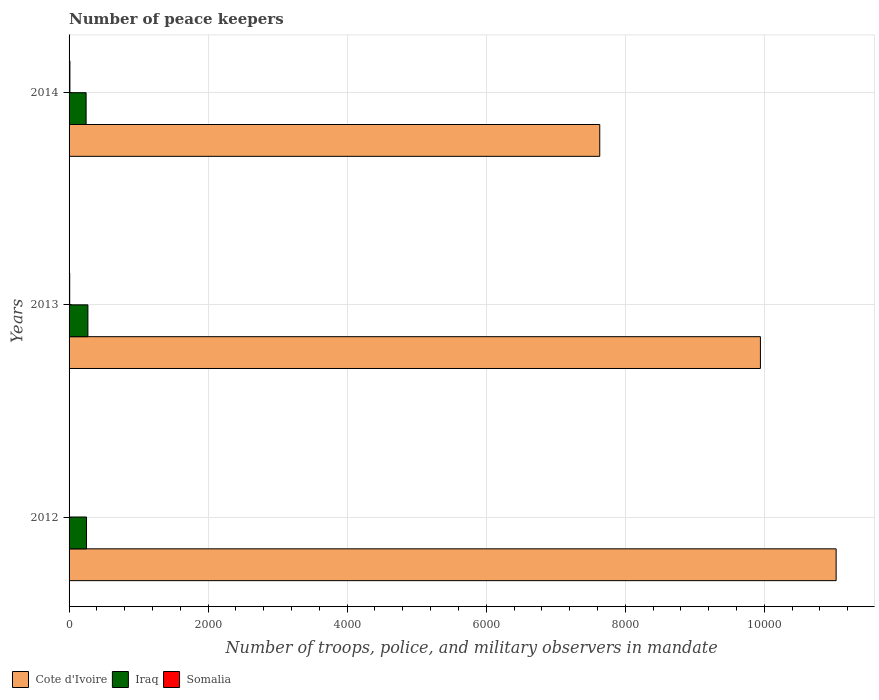How many different coloured bars are there?
Ensure brevity in your answer.  3. How many groups of bars are there?
Ensure brevity in your answer.  3. How many bars are there on the 2nd tick from the top?
Give a very brief answer. 3. How many bars are there on the 2nd tick from the bottom?
Provide a succinct answer. 3. What is the label of the 1st group of bars from the top?
Provide a short and direct response. 2014. What is the number of peace keepers in in Somalia in 2012?
Provide a short and direct response. 3. Across all years, what is the maximum number of peace keepers in in Somalia?
Make the answer very short. 12. Across all years, what is the minimum number of peace keepers in in Cote d'Ivoire?
Your answer should be compact. 7633. In which year was the number of peace keepers in in Iraq maximum?
Ensure brevity in your answer.  2013. What is the difference between the number of peace keepers in in Cote d'Ivoire in 2012 and that in 2013?
Give a very brief answer. 1089. What is the difference between the number of peace keepers in in Somalia in 2013 and the number of peace keepers in in Iraq in 2012?
Your response must be concise. -242. What is the average number of peace keepers in in Iraq per year?
Ensure brevity in your answer.  255.67. In the year 2014, what is the difference between the number of peace keepers in in Somalia and number of peace keepers in in Iraq?
Your response must be concise. -233. In how many years, is the number of peace keepers in in Iraq greater than 3600 ?
Your response must be concise. 0. Is the number of peace keepers in in Iraq in 2012 less than that in 2013?
Offer a terse response. Yes. What is the difference between the highest and the second highest number of peace keepers in in Iraq?
Give a very brief answer. 20. What does the 3rd bar from the top in 2012 represents?
Your answer should be compact. Cote d'Ivoire. What does the 1st bar from the bottom in 2014 represents?
Your answer should be compact. Cote d'Ivoire. How many bars are there?
Ensure brevity in your answer.  9. How many years are there in the graph?
Your answer should be very brief. 3. Does the graph contain grids?
Your answer should be very brief. Yes. Where does the legend appear in the graph?
Offer a terse response. Bottom left. How many legend labels are there?
Your answer should be compact. 3. What is the title of the graph?
Give a very brief answer. Number of peace keepers. Does "Venezuela" appear as one of the legend labels in the graph?
Your answer should be very brief. No. What is the label or title of the X-axis?
Provide a succinct answer. Number of troops, police, and military observers in mandate. What is the Number of troops, police, and military observers in mandate of Cote d'Ivoire in 2012?
Offer a terse response. 1.10e+04. What is the Number of troops, police, and military observers in mandate in Iraq in 2012?
Provide a short and direct response. 251. What is the Number of troops, police, and military observers in mandate in Somalia in 2012?
Your answer should be compact. 3. What is the Number of troops, police, and military observers in mandate in Cote d'Ivoire in 2013?
Your answer should be compact. 9944. What is the Number of troops, police, and military observers in mandate in Iraq in 2013?
Ensure brevity in your answer.  271. What is the Number of troops, police, and military observers in mandate of Somalia in 2013?
Offer a terse response. 9. What is the Number of troops, police, and military observers in mandate of Cote d'Ivoire in 2014?
Offer a very short reply. 7633. What is the Number of troops, police, and military observers in mandate in Iraq in 2014?
Provide a succinct answer. 245. Across all years, what is the maximum Number of troops, police, and military observers in mandate of Cote d'Ivoire?
Offer a terse response. 1.10e+04. Across all years, what is the maximum Number of troops, police, and military observers in mandate of Iraq?
Give a very brief answer. 271. Across all years, what is the maximum Number of troops, police, and military observers in mandate of Somalia?
Provide a short and direct response. 12. Across all years, what is the minimum Number of troops, police, and military observers in mandate in Cote d'Ivoire?
Keep it short and to the point. 7633. Across all years, what is the minimum Number of troops, police, and military observers in mandate of Iraq?
Keep it short and to the point. 245. Across all years, what is the minimum Number of troops, police, and military observers in mandate in Somalia?
Keep it short and to the point. 3. What is the total Number of troops, police, and military observers in mandate of Cote d'Ivoire in the graph?
Your answer should be very brief. 2.86e+04. What is the total Number of troops, police, and military observers in mandate of Iraq in the graph?
Your answer should be very brief. 767. What is the difference between the Number of troops, police, and military observers in mandate in Cote d'Ivoire in 2012 and that in 2013?
Make the answer very short. 1089. What is the difference between the Number of troops, police, and military observers in mandate in Cote d'Ivoire in 2012 and that in 2014?
Your response must be concise. 3400. What is the difference between the Number of troops, police, and military observers in mandate of Cote d'Ivoire in 2013 and that in 2014?
Provide a short and direct response. 2311. What is the difference between the Number of troops, police, and military observers in mandate of Cote d'Ivoire in 2012 and the Number of troops, police, and military observers in mandate of Iraq in 2013?
Provide a succinct answer. 1.08e+04. What is the difference between the Number of troops, police, and military observers in mandate in Cote d'Ivoire in 2012 and the Number of troops, police, and military observers in mandate in Somalia in 2013?
Your response must be concise. 1.10e+04. What is the difference between the Number of troops, police, and military observers in mandate in Iraq in 2012 and the Number of troops, police, and military observers in mandate in Somalia in 2013?
Provide a short and direct response. 242. What is the difference between the Number of troops, police, and military observers in mandate of Cote d'Ivoire in 2012 and the Number of troops, police, and military observers in mandate of Iraq in 2014?
Offer a very short reply. 1.08e+04. What is the difference between the Number of troops, police, and military observers in mandate in Cote d'Ivoire in 2012 and the Number of troops, police, and military observers in mandate in Somalia in 2014?
Give a very brief answer. 1.10e+04. What is the difference between the Number of troops, police, and military observers in mandate in Iraq in 2012 and the Number of troops, police, and military observers in mandate in Somalia in 2014?
Provide a succinct answer. 239. What is the difference between the Number of troops, police, and military observers in mandate of Cote d'Ivoire in 2013 and the Number of troops, police, and military observers in mandate of Iraq in 2014?
Your answer should be compact. 9699. What is the difference between the Number of troops, police, and military observers in mandate in Cote d'Ivoire in 2013 and the Number of troops, police, and military observers in mandate in Somalia in 2014?
Keep it short and to the point. 9932. What is the difference between the Number of troops, police, and military observers in mandate in Iraq in 2013 and the Number of troops, police, and military observers in mandate in Somalia in 2014?
Provide a succinct answer. 259. What is the average Number of troops, police, and military observers in mandate in Cote d'Ivoire per year?
Provide a short and direct response. 9536.67. What is the average Number of troops, police, and military observers in mandate in Iraq per year?
Provide a short and direct response. 255.67. In the year 2012, what is the difference between the Number of troops, police, and military observers in mandate of Cote d'Ivoire and Number of troops, police, and military observers in mandate of Iraq?
Provide a succinct answer. 1.08e+04. In the year 2012, what is the difference between the Number of troops, police, and military observers in mandate of Cote d'Ivoire and Number of troops, police, and military observers in mandate of Somalia?
Give a very brief answer. 1.10e+04. In the year 2012, what is the difference between the Number of troops, police, and military observers in mandate in Iraq and Number of troops, police, and military observers in mandate in Somalia?
Your answer should be compact. 248. In the year 2013, what is the difference between the Number of troops, police, and military observers in mandate in Cote d'Ivoire and Number of troops, police, and military observers in mandate in Iraq?
Keep it short and to the point. 9673. In the year 2013, what is the difference between the Number of troops, police, and military observers in mandate of Cote d'Ivoire and Number of troops, police, and military observers in mandate of Somalia?
Offer a very short reply. 9935. In the year 2013, what is the difference between the Number of troops, police, and military observers in mandate of Iraq and Number of troops, police, and military observers in mandate of Somalia?
Provide a succinct answer. 262. In the year 2014, what is the difference between the Number of troops, police, and military observers in mandate of Cote d'Ivoire and Number of troops, police, and military observers in mandate of Iraq?
Ensure brevity in your answer.  7388. In the year 2014, what is the difference between the Number of troops, police, and military observers in mandate in Cote d'Ivoire and Number of troops, police, and military observers in mandate in Somalia?
Provide a short and direct response. 7621. In the year 2014, what is the difference between the Number of troops, police, and military observers in mandate of Iraq and Number of troops, police, and military observers in mandate of Somalia?
Ensure brevity in your answer.  233. What is the ratio of the Number of troops, police, and military observers in mandate of Cote d'Ivoire in 2012 to that in 2013?
Provide a short and direct response. 1.11. What is the ratio of the Number of troops, police, and military observers in mandate of Iraq in 2012 to that in 2013?
Your answer should be very brief. 0.93. What is the ratio of the Number of troops, police, and military observers in mandate of Somalia in 2012 to that in 2013?
Offer a very short reply. 0.33. What is the ratio of the Number of troops, police, and military observers in mandate of Cote d'Ivoire in 2012 to that in 2014?
Provide a succinct answer. 1.45. What is the ratio of the Number of troops, police, and military observers in mandate in Iraq in 2012 to that in 2014?
Provide a succinct answer. 1.02. What is the ratio of the Number of troops, police, and military observers in mandate in Somalia in 2012 to that in 2014?
Your response must be concise. 0.25. What is the ratio of the Number of troops, police, and military observers in mandate of Cote d'Ivoire in 2013 to that in 2014?
Give a very brief answer. 1.3. What is the ratio of the Number of troops, police, and military observers in mandate in Iraq in 2013 to that in 2014?
Your response must be concise. 1.11. What is the ratio of the Number of troops, police, and military observers in mandate of Somalia in 2013 to that in 2014?
Give a very brief answer. 0.75. What is the difference between the highest and the second highest Number of troops, police, and military observers in mandate in Cote d'Ivoire?
Your answer should be compact. 1089. What is the difference between the highest and the second highest Number of troops, police, and military observers in mandate in Somalia?
Give a very brief answer. 3. What is the difference between the highest and the lowest Number of troops, police, and military observers in mandate in Cote d'Ivoire?
Provide a short and direct response. 3400. What is the difference between the highest and the lowest Number of troops, police, and military observers in mandate of Somalia?
Offer a very short reply. 9. 